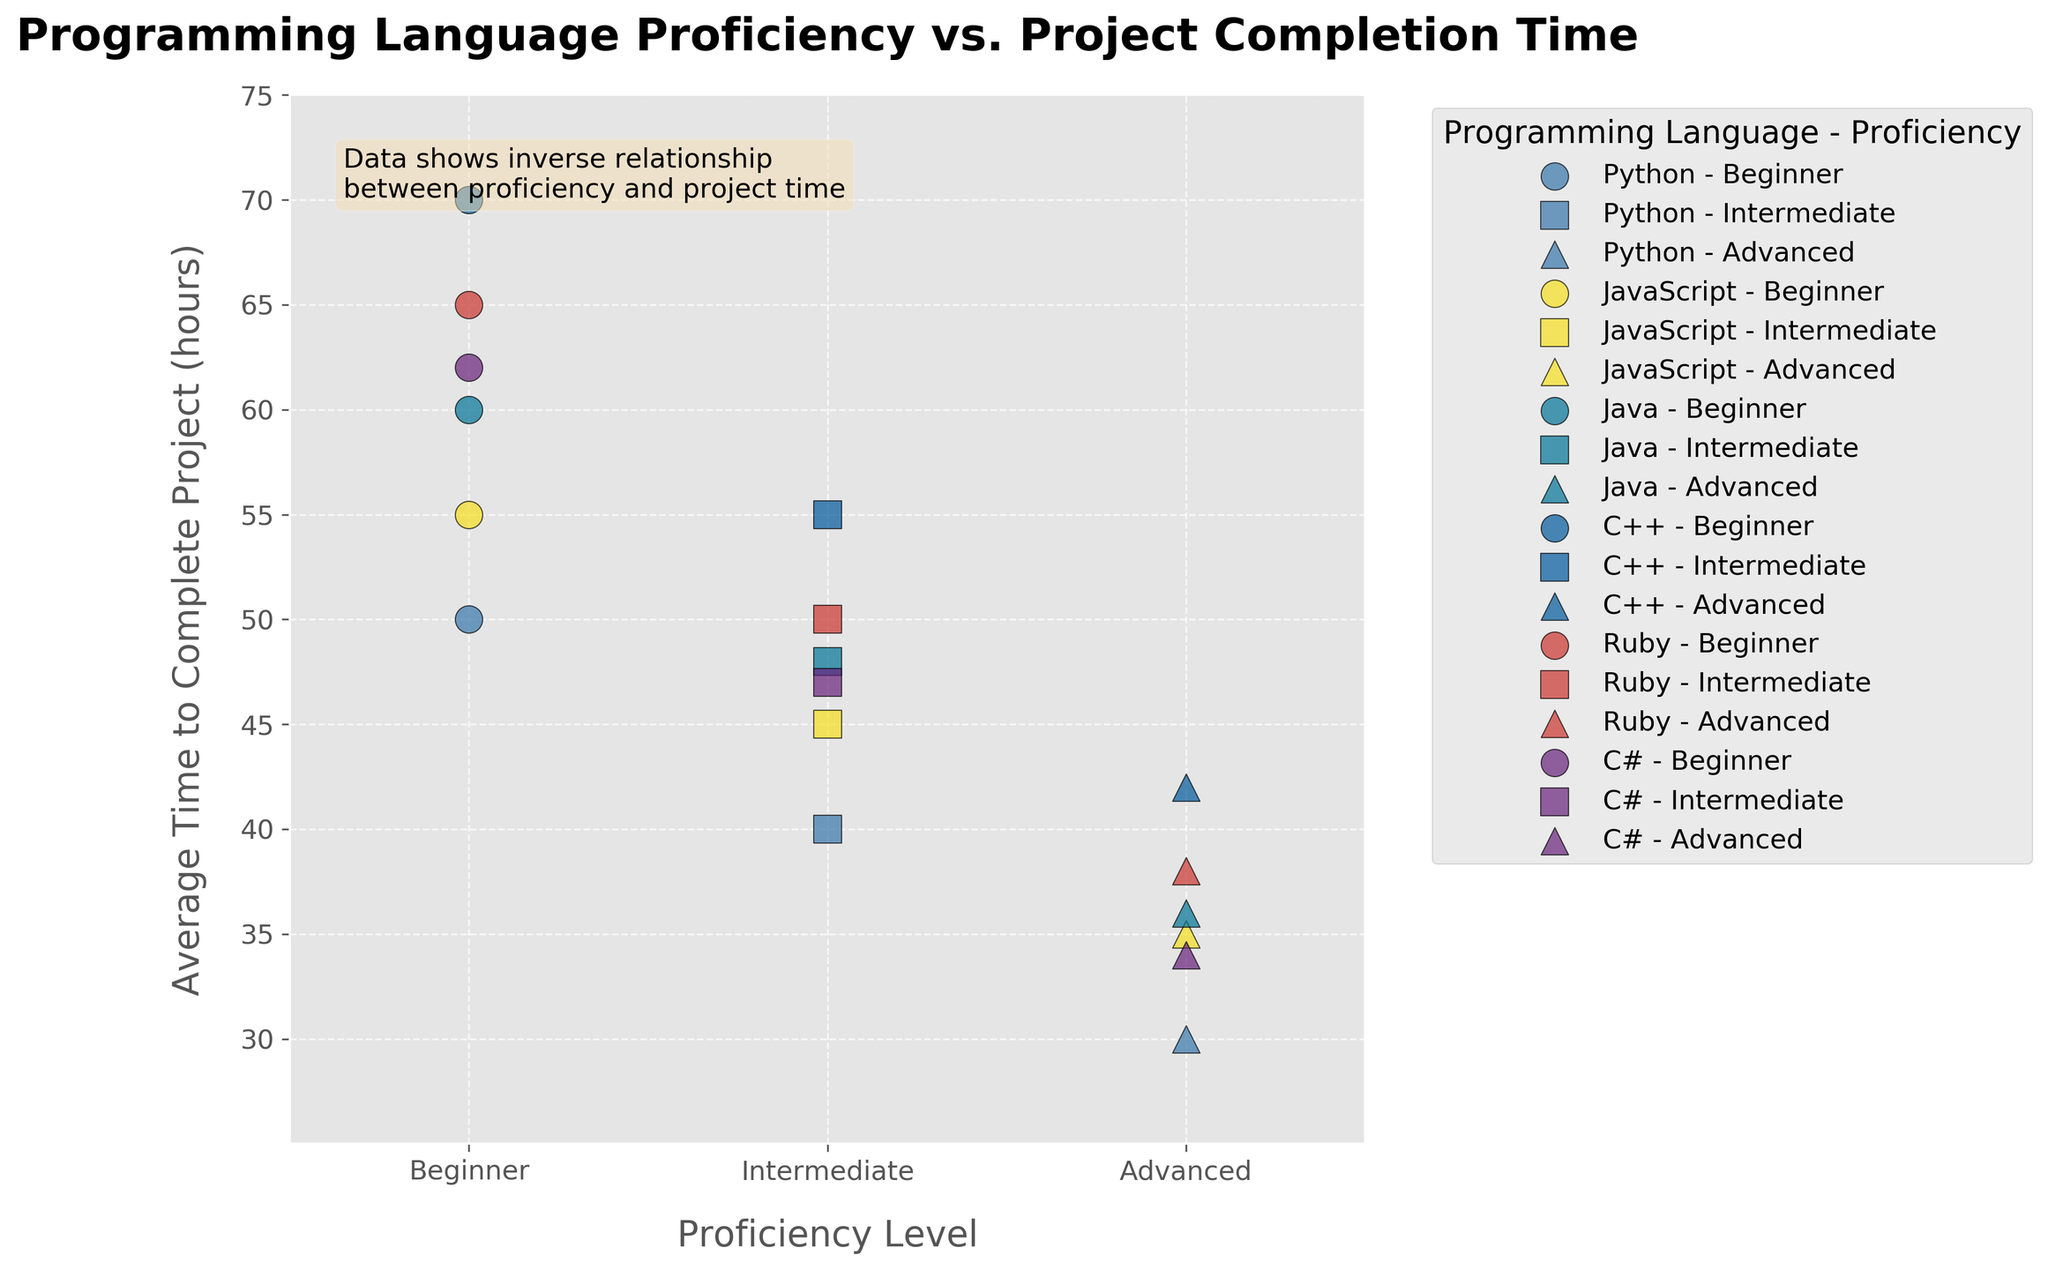How many proficiency levels are there? The x-axis labels each proficiency level, showing three distinct categories: Beginner, Intermediate, and Advanced.
Answer: 3 Which programming language takes the longest average time to complete a project at the beginner level? The scatter plot shows that C++ at the beginner level has the highest average time, as indicated by the highest point on the y-axis for beginners.
Answer: C++ How does the average time to complete a project change with proficiency level for Python? For Python, the average time decreases as proficiency level increases: 50 hours for Beginners, 40 hours for Intermediates, and 30 hours for Advanced users, as indicated by the descending order of points on the y-axis.
Answer: Decreases Which programming language has the smallest difference in average time to complete a project between beginner and advanced levels? By observing the vertical distances between the points for Beginner and Advanced levels for each language, JavaScript has the smallest difference (55 hours for Beginners and 35 hours for Advanced users, a difference of 20 hours).
Answer: JavaScript What can be inferred about the relationship between proficiency level and average time taken to complete a project? The plot shows a general downward trend in the average time taken to complete a project as proficiency level increases, suggesting an inverse relationship between proficiency and project time.
Answer: Inverse relationship What is the average time to complete a project for Intermediate proficiency in C++? Locate the data point for Intermediate proficiency level under the C++ category, which is positioned at the y-axis value of 55 hours.
Answer: 55 hours How many data points are plotted for each programming language? Each programming language has three data points corresponding to the three proficiency levels: Beginner, Intermediate, and Advanced.
Answer: 3 